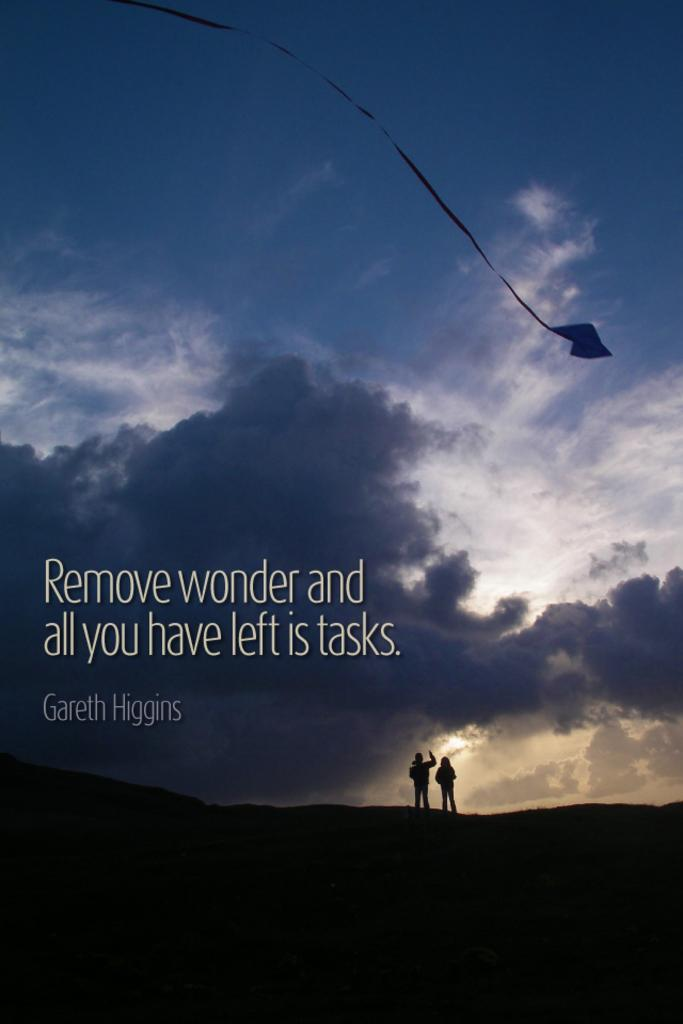What is the main subject of the image? The main subject of the image is persons on a hill. What can be seen in the background of the image? There is a kite visible in the background of the image, and the sky is also visible. What is the condition of the sky in the image? The sky is visible in the background of the image, and clouds are present. What type of home can be seen in the image? There is no home present in the image; it features persons on a hill with a kite and clouds in the sky. How many baskets are visible in the image? There are no baskets present in the image. 